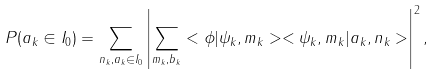Convert formula to latex. <formula><loc_0><loc_0><loc_500><loc_500>P ( a _ { k } \in I _ { 0 } ) = \sum _ { n _ { k } , a _ { k } \in I _ { 0 } } \left | \sum _ { m _ { k } , b _ { k } } < \phi | \psi _ { k } , m _ { k } > < \psi _ { k } , m _ { k } | a _ { k } , n _ { k } > \right | ^ { 2 } ,</formula> 